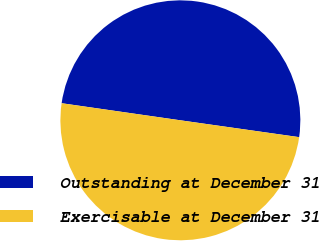Convert chart to OTSL. <chart><loc_0><loc_0><loc_500><loc_500><pie_chart><fcel>Outstanding at December 31<fcel>Exercisable at December 31<nl><fcel>49.97%<fcel>50.03%<nl></chart> 